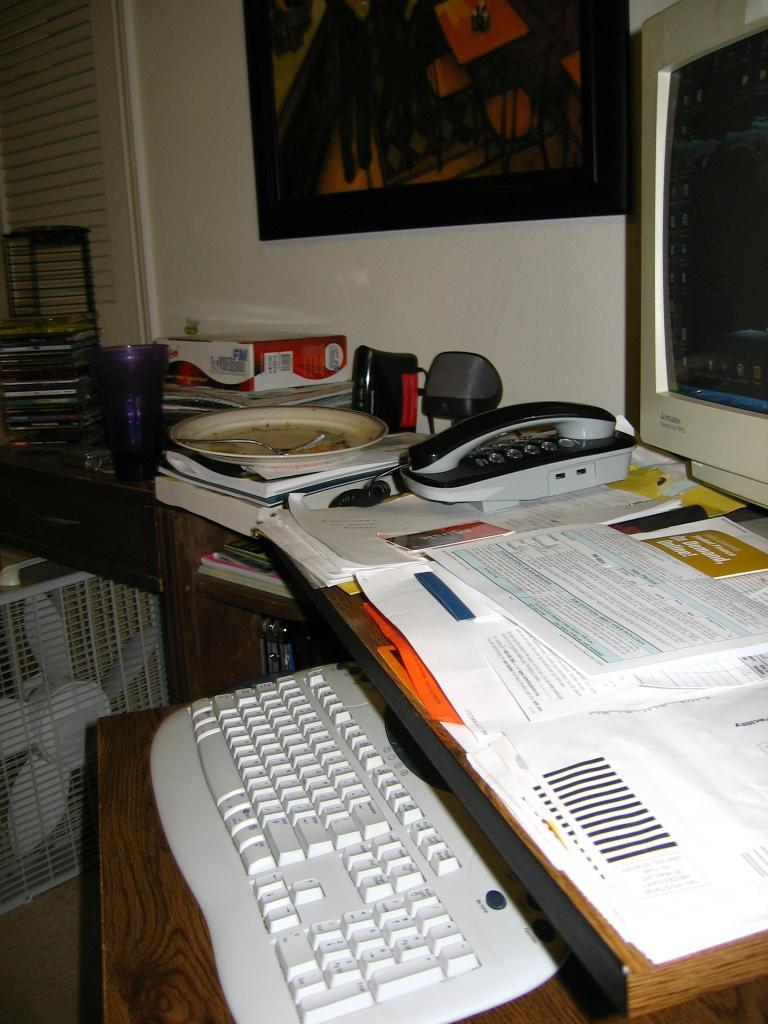What type of table is in the image? There is a wooden table in the image. What electronic device is on the table? A computer is present on the table. What is used for typing on the computer? A keyboard is on the table. What communication device is on the table? A telephone is on the table. What reading materials are on the table? There are books on the table. What writing materials are on the table? Papers are on the table. What additional item is in the image? There is a cooler in the image. What type of stew is being cooked on the table in the image? There is no stew being cooked on the table in the image; it is a wooden table with various items on it. 